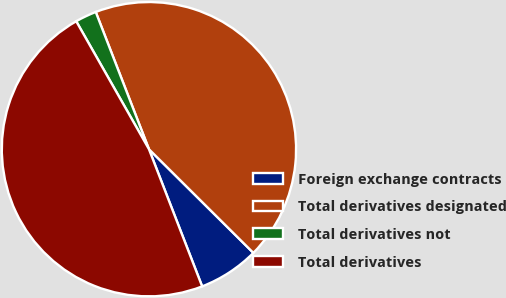Convert chart. <chart><loc_0><loc_0><loc_500><loc_500><pie_chart><fcel>Foreign exchange contracts<fcel>Total derivatives designated<fcel>Total derivatives not<fcel>Total derivatives<nl><fcel>6.67%<fcel>43.33%<fcel>2.34%<fcel>47.66%<nl></chart> 